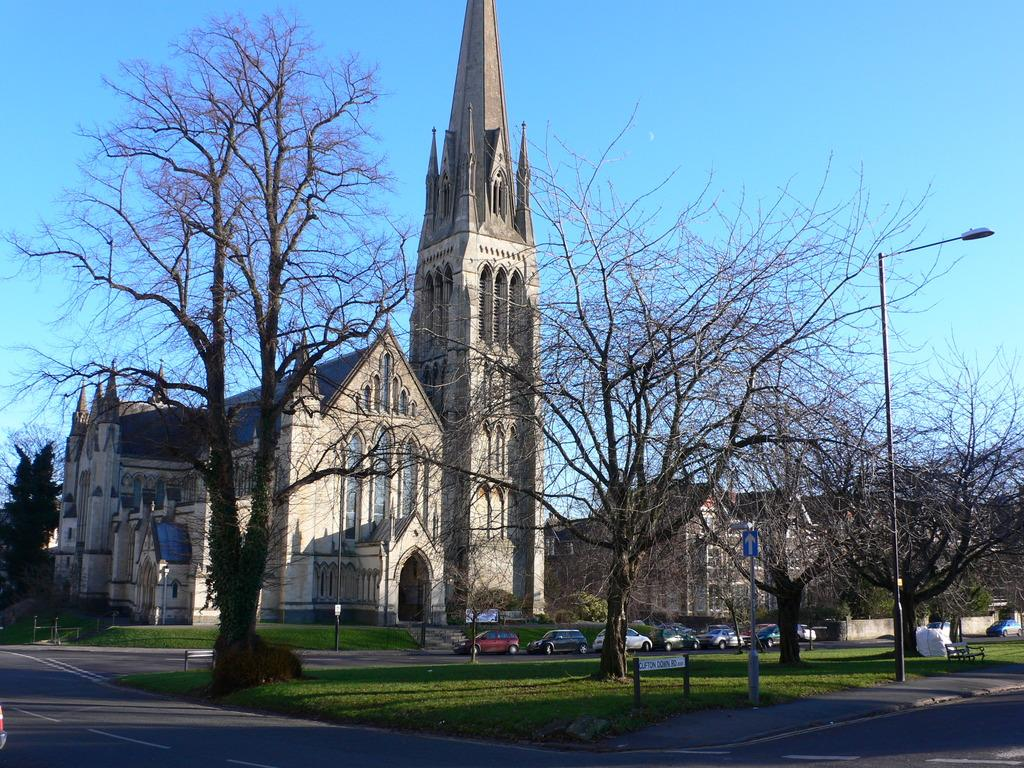What type of structure is in the image? There is a building in the image. What is in front of the building? There are trees in front of the building. What else can be seen in the image besides the building and trees? Vehicles, a road, a bench, a pole, and a light are visible in the image. What is attached to the pole? A light is attached to the pole. What is visible at the top of the image? The sky is visible at the top of the image. What type of cave is located behind the building in the image? There is no cave present in the image; it features a building with trees, vehicles, a road, a bench, a pole, and a light. What type of birthday celebration is happening in the image? There is no birthday celebration depicted in the image. 